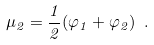Convert formula to latex. <formula><loc_0><loc_0><loc_500><loc_500>\mu _ { 2 } = \frac { 1 } { 2 } ( \varphi _ { 1 } + \varphi _ { 2 } ) \ .</formula> 